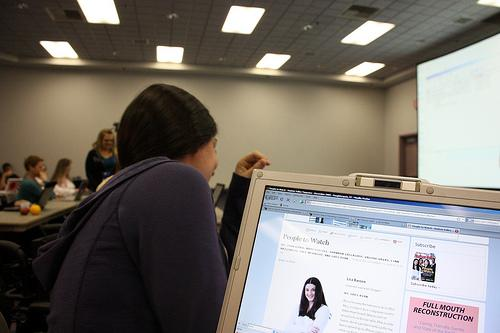Mention the color and position of the laptop screens depicted in the image. There is a silver laptop screen turned on and another laptop screen present in the background. What kind of light source is present in the image and describe the ceiling features? Fluorescent lights and rectangular white lights are on the ceiling along with square tiles and ventilation vents. Enumerate the types of fruit that can be seen on the table in the image. There are an apple and an orange on the table. What is the main task people are performing in the image, and what devices are they using for it? People are working on their computers, including two laptops in the background. Describe the object on the desk besides the fruit and provide its color. An orange is on the desk, and it has a bright orange color. What is the main area in the image where most activities are happening? The foreground with a woman sitting behind the computer screen and people working on their computers. What is the nature of the content displayed on the computer screens in the image? There is a woman on a computer screen, a pink advertisement, and a web page displayed on the screens. Count the number of people in the image and mention the hair color of the woman in the background. There are multiple people in the image, and the woman in the background has blonde hair. What kind of device is mounted on the wall in the image? There is a projector mounted on the wall and a large projection screen. Identify the type of clothing the main subject (a woman) is wearing, and describe its color. The main subject is wearing a purple hoodie. Is there a blue open umbrella on the desk? No, it's not mentioned in the image. Point out the person with the skull cap and hoodie top in this picture. The person is found at coordinates X:59 Y:82 with the dimensions Width:189 Height:189. Do the people in the background appear to be sitting at desks? Yes, they are sitting down at desks. Is the woman on the computer screen wearing a green hat? There is no mention of a green hat, and the woman is described as having "shiny brown hair" and "dark colored hair." Find the location of the projector on the wall. It is located at coordinates X:411 Y:40 with dimensions Width:87 Height:87. What fruit are displayed on the table in the scene? Apple and orange What is the color of the one of the projector screens in the image? Giant white glowing screen How many laptops can be seen in the background? Two laptops Is there a yellow coffee mug next to the fruit on the table? Only "apple and orange fruit" are mentioned on the table, and there is no mention of a coffee mug or any other tableware. Where is the woman with center parted long dark hair? She is positioned at coordinates X:296 Y:275 with dimensions Width:32 Height:32. Identify the type of shirt the woman in the foreground is wearing. A purple sweatshirt with a hood What is the color of the hair of the woman sitting behind the computer screen? Shiny brown Is the projector displaying a movie scene on the wall? The projector is described as being on the wall, but there is no information about what it is displaying or if it is projecting an image at all. A) The computer screen shows a woman holding an orange.  C) The woman in the background is wearing a green shirt. What type of light fixture is located at X:254 Y:49? Flourescent light Describe the light fixtures you can see in the image. There are rectangle light fixtures on the ceiling, gray squares on the ceiling, flourescent light, and also ceiling overhead rectangular white lights. Is the computer screen on or off? On What color is the woman's hoodie in the image? Purple Can you identify any fruit on the table in the image? If so, what are they? Yes, there are an apple and an orange on the table. Describe the ceiling in the image. The ceiling has square tiles, lights, and ventilation vents. What can you see on the top of the laptop screen latch? URL box on the internet browser. What type of advertisement is displayed on the computer screen? A pink advertisement with a woman's picture. What kind of website is displayed on the computer screen? An advertisement website with a woman's picture and a pink section. 